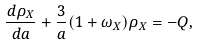<formula> <loc_0><loc_0><loc_500><loc_500>\frac { d \rho _ { X } } { d a } + \frac { 3 } { a } ( 1 + \omega _ { X } ) \rho _ { X } = - Q ,</formula> 